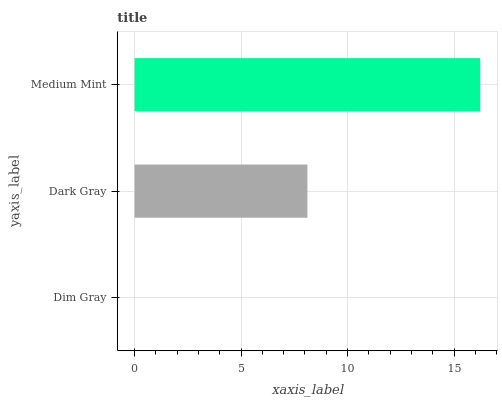Is Dim Gray the minimum?
Answer yes or no. Yes. Is Medium Mint the maximum?
Answer yes or no. Yes. Is Dark Gray the minimum?
Answer yes or no. No. Is Dark Gray the maximum?
Answer yes or no. No. Is Dark Gray greater than Dim Gray?
Answer yes or no. Yes. Is Dim Gray less than Dark Gray?
Answer yes or no. Yes. Is Dim Gray greater than Dark Gray?
Answer yes or no. No. Is Dark Gray less than Dim Gray?
Answer yes or no. No. Is Dark Gray the high median?
Answer yes or no. Yes. Is Dark Gray the low median?
Answer yes or no. Yes. Is Dim Gray the high median?
Answer yes or no. No. Is Dim Gray the low median?
Answer yes or no. No. 